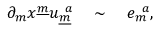Convert formula to latex. <formula><loc_0><loc_0><loc_500><loc_500>\partial _ { m } x ^ { \underline { m } } u _ { \underline { m } } ^ { a \sim e _ { m } ^ { a } ,</formula> 